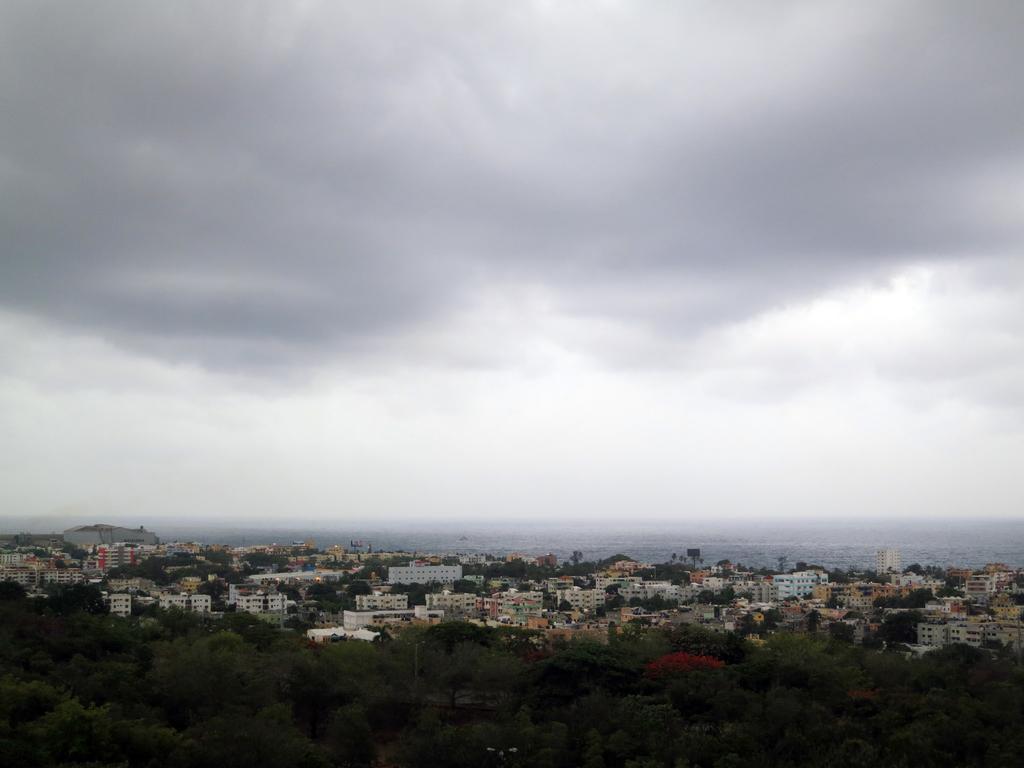Describe this image in one or two sentences. In this image, we can see buildings, trees, poles, towers and there is water. At the top, there are clouds in the sky. 